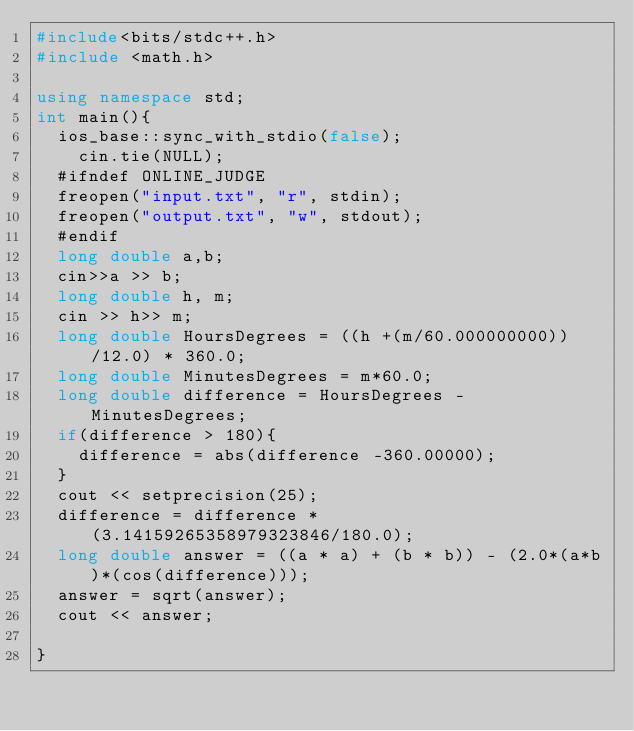<code> <loc_0><loc_0><loc_500><loc_500><_C++_>#include<bits/stdc++.h>
#include <math.h> 

using namespace std;
int main(){
	ios_base::sync_with_stdio(false);
    cin.tie(NULL);
	#ifndef ONLINE_JUDGE
	freopen("input.txt", "r", stdin);
	freopen("output.txt", "w", stdout);
	#endif
	long double a,b;
	cin>>a >> b;
	long double h, m;
	cin >> h>> m;
	long double HoursDegrees = ((h +(m/60.000000000))/12.0) * 360.0;
	long double MinutesDegrees = m*60.0;
	long double difference = HoursDegrees - MinutesDegrees;
	if(difference > 180){
		difference = abs(difference -360.00000);
	}
	cout << setprecision(25);
	difference = difference * (3.14159265358979323846/180.0);
	long double answer = ((a * a) + (b * b)) - (2.0*(a*b)*(cos(difference)));
	answer = sqrt(answer);
	cout << answer;

}</code> 